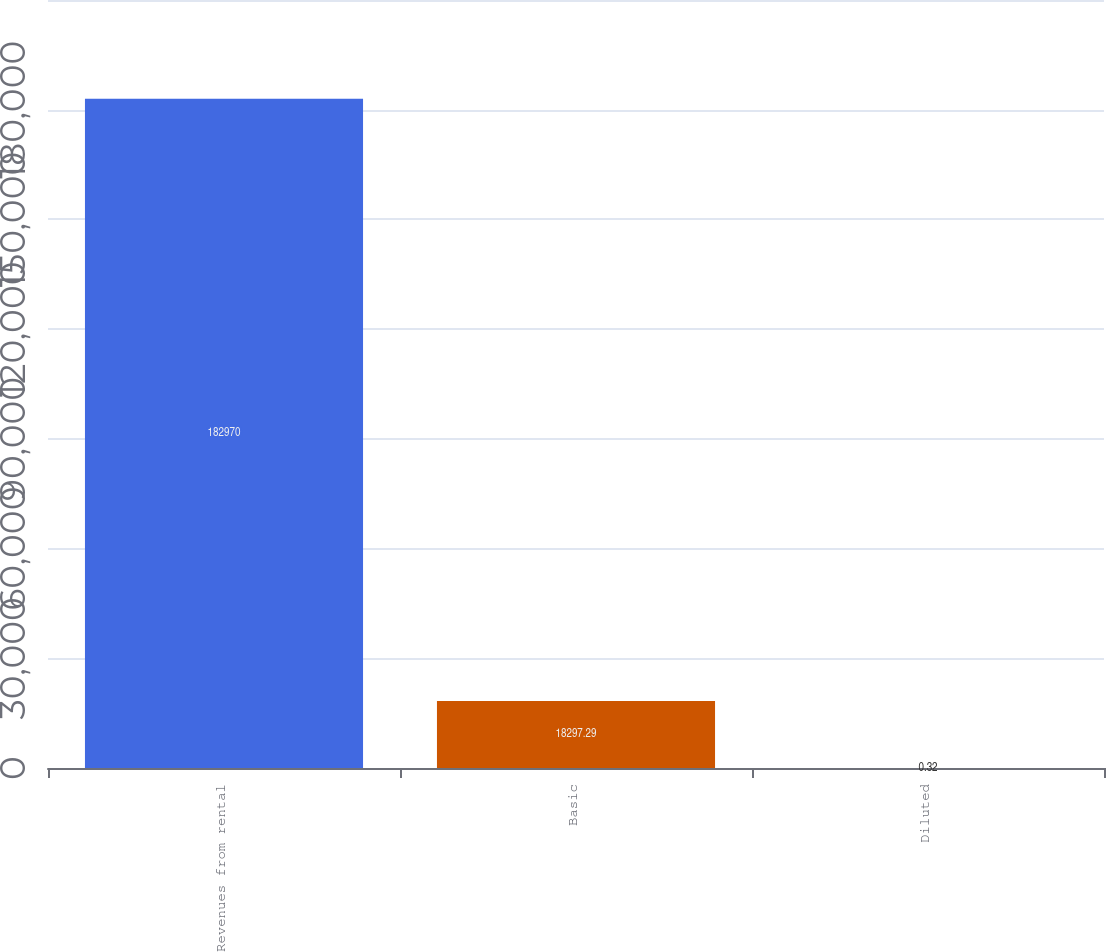Convert chart. <chart><loc_0><loc_0><loc_500><loc_500><bar_chart><fcel>Revenues from rental<fcel>Basic<fcel>Diluted<nl><fcel>182970<fcel>18297.3<fcel>0.32<nl></chart> 